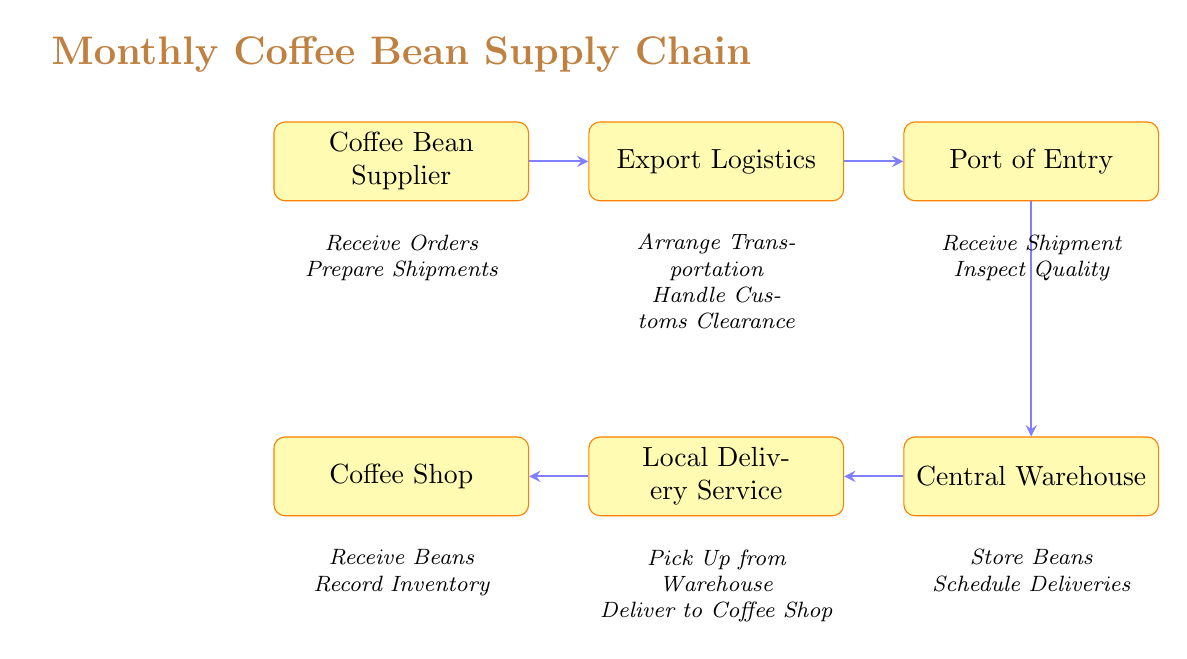What is the first step in the coffee bean supply chain? The diagram indicates that the first node is "Coffee Bean Supplier," which is the starting point of the supply chain.
Answer: Coffee Bean Supplier How many nodes are present in the diagram? By counting the listed nodes—Coffee Bean Supplier, Export Logistics, Port of Entry, Central Warehouse, Local Delivery Service, and Coffee Shop—we find that there are six distinct nodes in total.
Answer: 6 What action does the "Export Logistics" node perform? The diagram states two actions linked to "Export Logistics": "Arrange Transportation" and "Handle Customs Clearance." Therefore, any of these actions can serve as a correct answer.
Answer: Arrange Transportation Which node follows "Port of Entry"? The structure indicates the flow from "Port of Entry" leading directly to the "Central Warehouse," as it is depicted as the next step in the process.
Answer: Central Warehouse What is the final destination of the coffee bean supply chain? The flow chart ends at the "Coffee Shop," which is where the entire supply chain is aimed at delivering the beans.
Answer: Coffee Shop Why does the "Local Delivery Service" connect to the "Coffee Shop"? The connection from "Local Delivery Service" to "Coffee Shop" signifies that the delivery service's role is to transport the beans from the warehouse to the shop, completing the supply chain process.
Answer: To deliver beans What is the action taken by the "Central Warehouse"? Within the "Central Warehouse" node, the actions specified are "Store Beans" and "Schedule Deliveries," thus any of these would accurately reflect what occurs at this stage.
Answer: Store Beans Which node is responsible for customs clearance? Based on the diagram, "Export Logistics" encompasses the action of "Handle Customs Clearance," making it the node responsible for that process.
Answer: Export Logistics How many connections are there in the diagram? By examining the connections, we can count five links between nodes: from "supplier" to "export," "export" to "port," "port" to "warehouse," "warehouse" to "delivery," and "delivery" to "shop," resulting in five connections total.
Answer: 5 